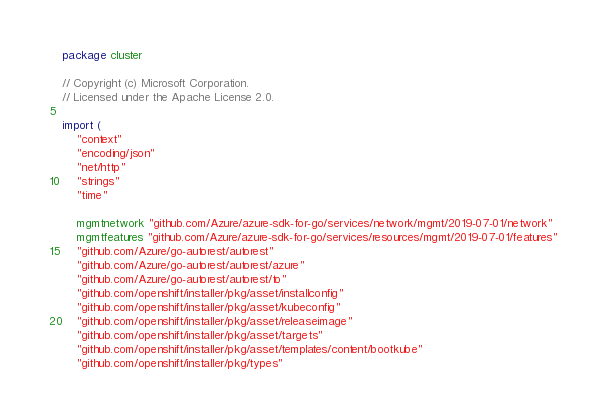<code> <loc_0><loc_0><loc_500><loc_500><_Go_>package cluster

// Copyright (c) Microsoft Corporation.
// Licensed under the Apache License 2.0.

import (
	"context"
	"encoding/json"
	"net/http"
	"strings"
	"time"

	mgmtnetwork "github.com/Azure/azure-sdk-for-go/services/network/mgmt/2019-07-01/network"
	mgmtfeatures "github.com/Azure/azure-sdk-for-go/services/resources/mgmt/2019-07-01/features"
	"github.com/Azure/go-autorest/autorest"
	"github.com/Azure/go-autorest/autorest/azure"
	"github.com/Azure/go-autorest/autorest/to"
	"github.com/openshift/installer/pkg/asset/installconfig"
	"github.com/openshift/installer/pkg/asset/kubeconfig"
	"github.com/openshift/installer/pkg/asset/releaseimage"
	"github.com/openshift/installer/pkg/asset/targets"
	"github.com/openshift/installer/pkg/asset/templates/content/bootkube"
	"github.com/openshift/installer/pkg/types"</code> 